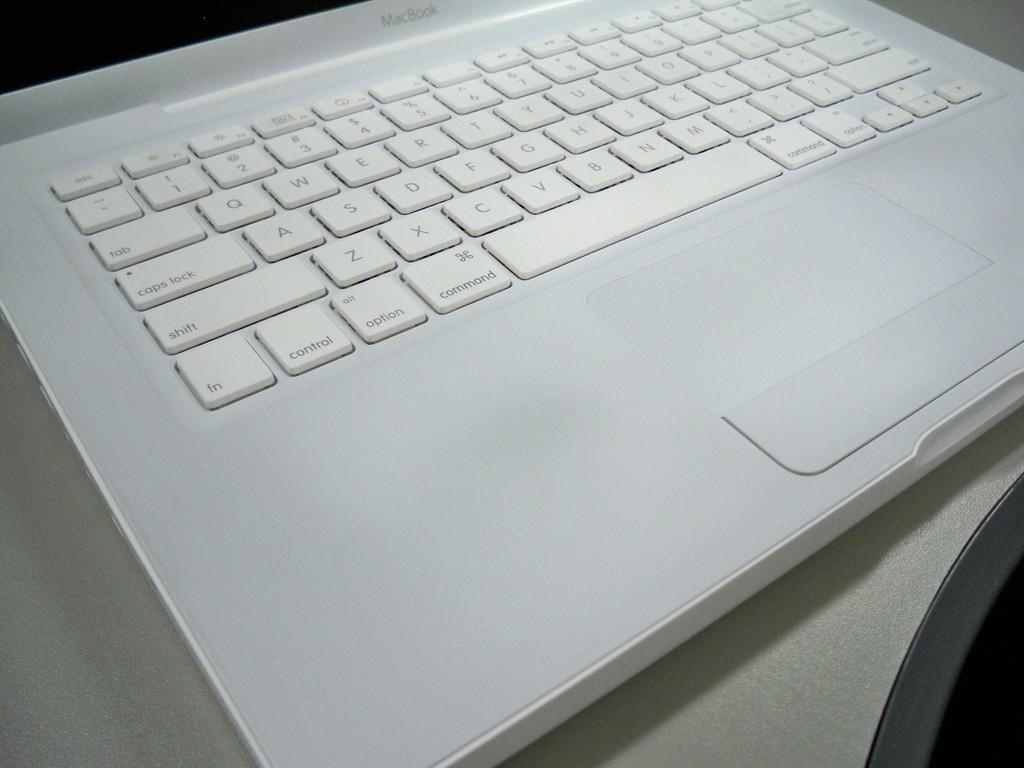What type of computer is visible in the image? There is a MacBook in the image. What feature is present on the MacBook? The MacBook has a keypad. What color is the MacBook? The MacBook is silver in color. Where is the MacBook located in the image? The MacBook is placed on a table. What type of crown is placed on the MacBook in the image? There is no crown present in the image; it features a MacBook on a table. How does the achiever interact with the MacBook in the image? There is no achiever present in the image; it only shows a MacBook on a table. 